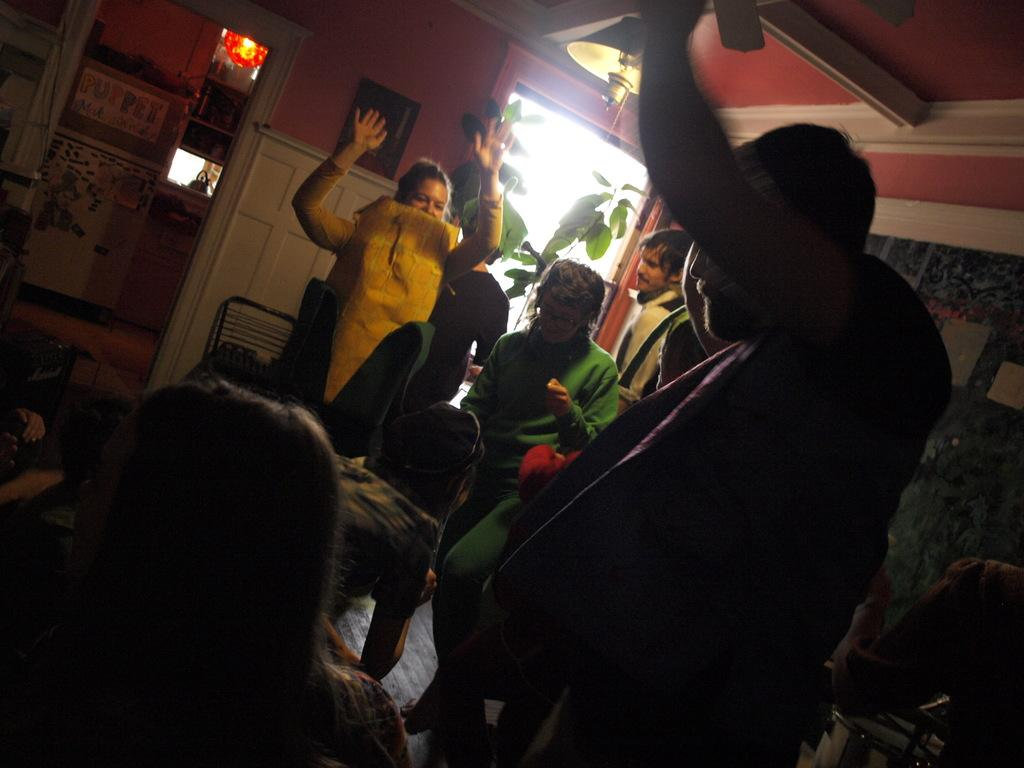What are the people in the image wearing? The people in the image are wearing different color dresses. What else can be seen in the image besides the people? There are objects and plants in the image. Can you describe the furniture in the image? There is a chair in the image. How is the frame positioned in the image? The frame is attached to the wall in the image. How does the expert demonstrate their knowledge in the image? There is no expert present in the image, and therefore no demonstration of knowledge can be observed. 